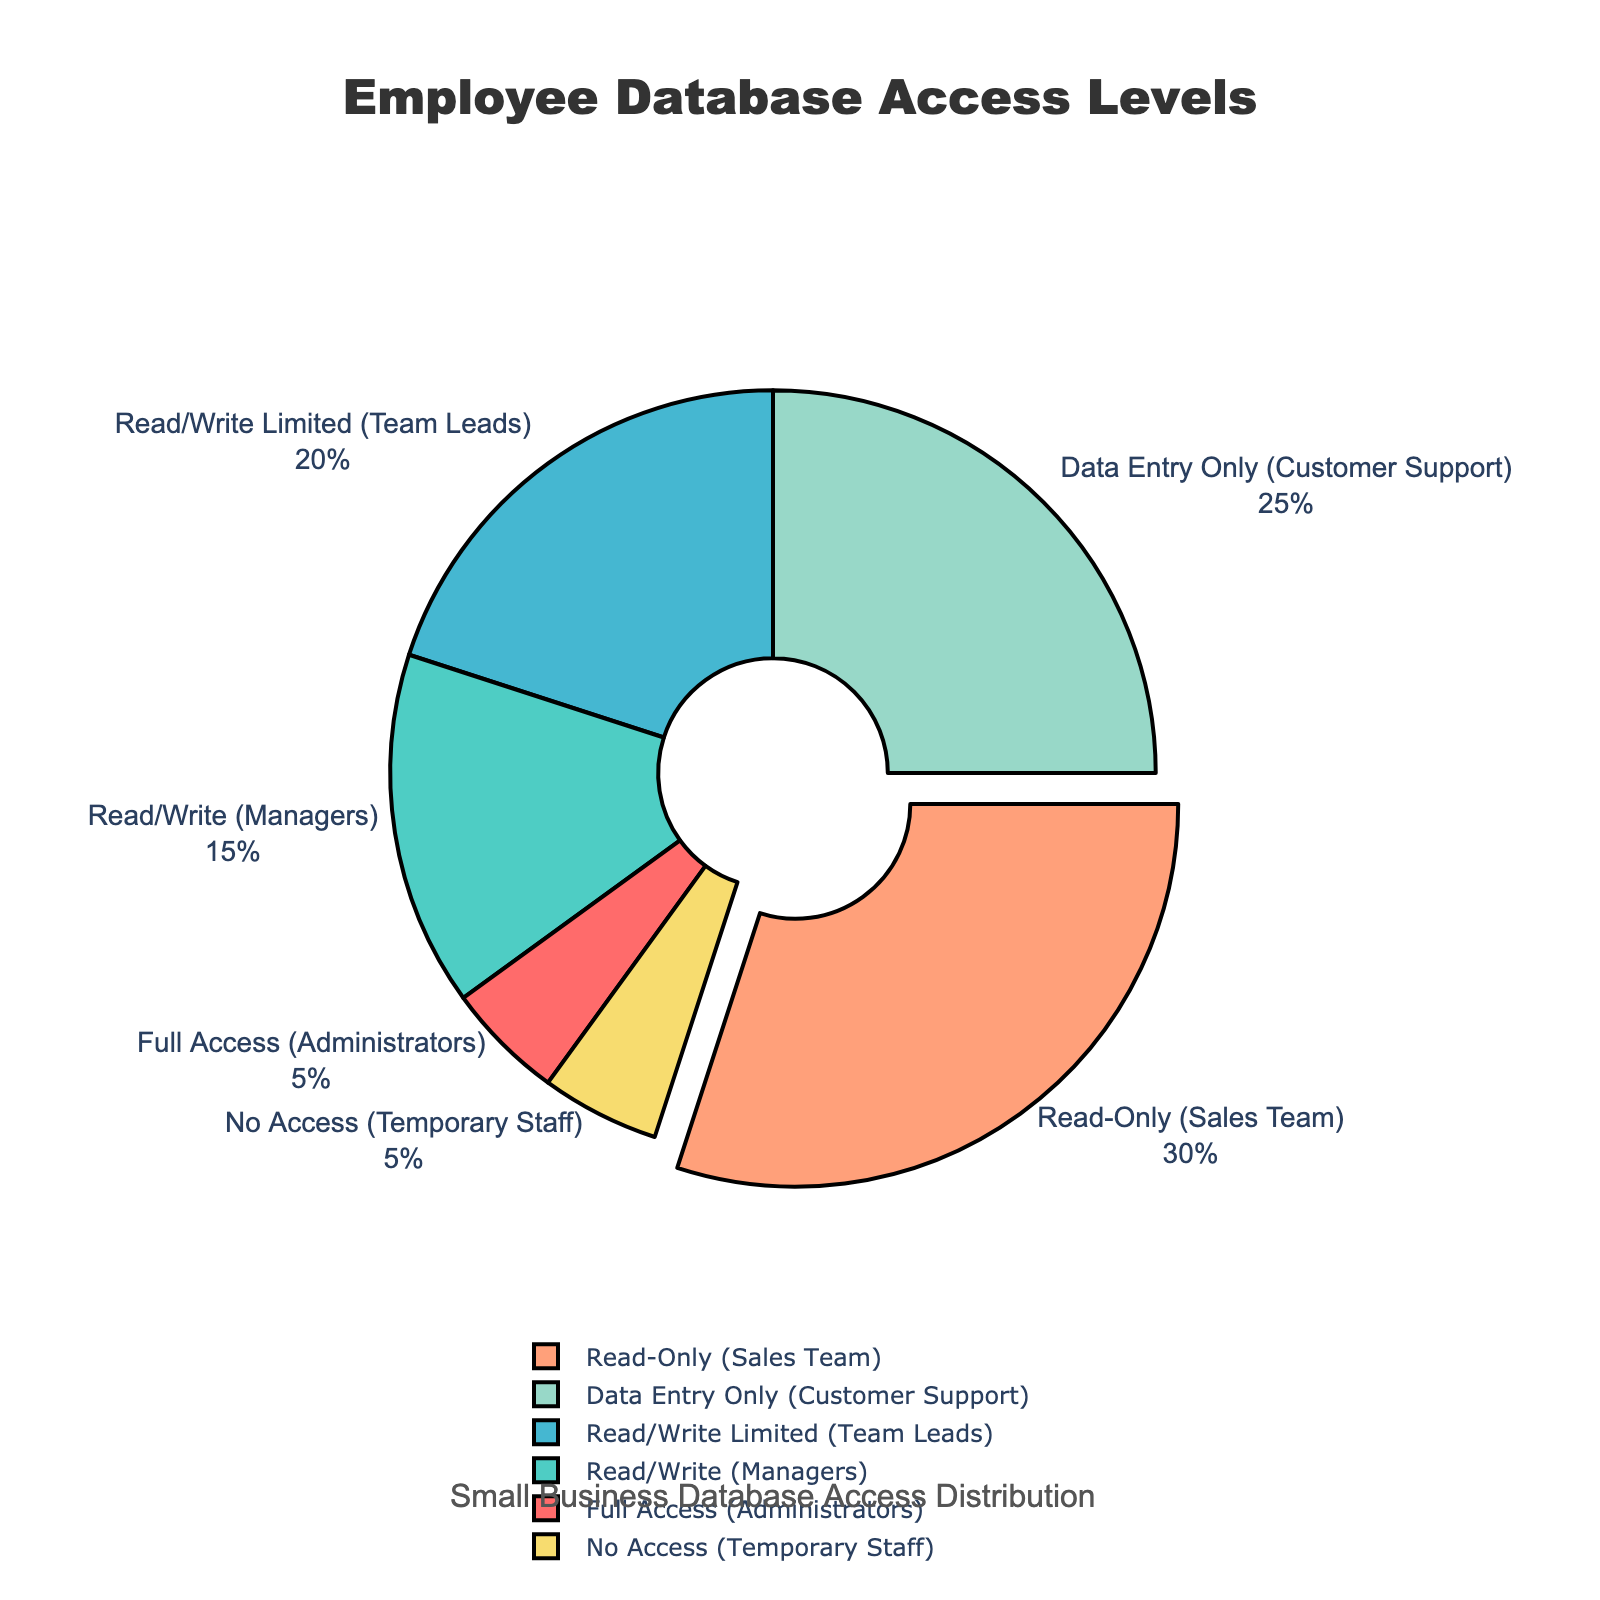What percentage of employees have read/write or higher access? To determine this, sum the percentages of employees with Full Access, Read/Write, and Read/Write Limited access. The percentages are 5% (Full Access) + 15% (Read/Write) + 20% (Read/Write Limited). Thus, the sum is 5 + 15 + 20 = 40%.
Answer: 40% Which group has the highest percentage of employees, and what is that percentage? The Sales Team has the highest percentage of employees. By looking at the pie chart, it is labeled with the highest percentage of 30%.
Answer: Sales Team, 30% How does the percentage of employees with Full Access compare to those with Data Entry Only access? The percentage of employees with Full Access is 5%, while those with Data Entry Only access is 25%. Compare the two by subtracting the smaller percentage from the larger percentage: 25% - 5% = 20%.
Answer: Employees with Data Entry Only access have 20% more representation than those with Full Access What is the total percentage of employees who either have no access or data entry only access? Add the percentage of employees with No Access (5%) and Data Entry Only access (25%). Thus, the sum is 5 + 25 = 30%.
Answer: 30% Which color in the pie chart represents the 'Temporary Staff' access level, and how much percentage does this group constitute? The Temporary Staff group is associated with No Access, which is 5%. Looking at the pie chart, No Access is represented by a specific color, which is yellow as per the slice with the 5% label.
Answer: Yellow, 5% Is the percentage of employees with Read-Only access more than the combined percentage of those with Full Access and No Access? First, combine the percentages of employees with Full Access (5%) and No Access (5%), resulting in 5 + 5 = 10%. The percentage of employees with Read-Only access is 30%. Since 30% > 10%, the statement is true.
Answer: Yes If you were to divide employees into two groups: those with any level of write access and those without any write access, what percentage falls into each group? Employees with any level of write access include Full Access (5%), Read/Write (15%), and Read/Write Limited (20%), summing up to 5 + 15 + 20 = 40%. Those without any write access include Read-Only (30%), Data Entry Only (25%), and No Access (5%), adding to 30 + 25 + 5 = 60%.
Answer: 40% with write access, 60% without write access What is the difference between the percentage of employees in the Sales Team and Customer Support groups? The percentage of employees in the Sales Team is 30%, and in the Customer Support group is 25%. The difference is computed by subtracting 25% from 30%, resulting in 30 - 25 = 5%.
Answer: 5% Which access level is represented by the largest pulled-out slice, and why? The largest pulled-out slice represents the highest percentage, which is the Read-Only access level at 30%. This is the visually indicated slice that is pulled out from the pie chart.
Answer: Read-Only, 30% 